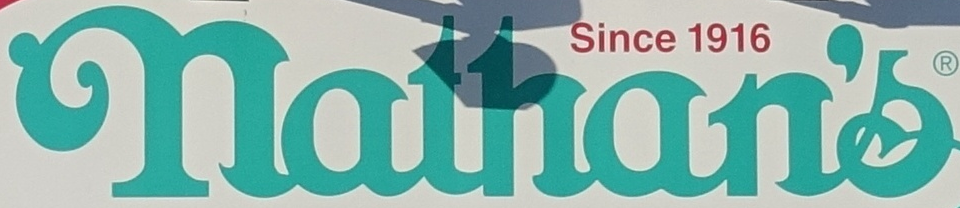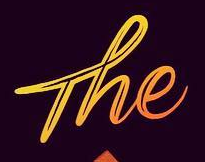Read the text content from these images in order, separated by a semicolon. nathan's; The 